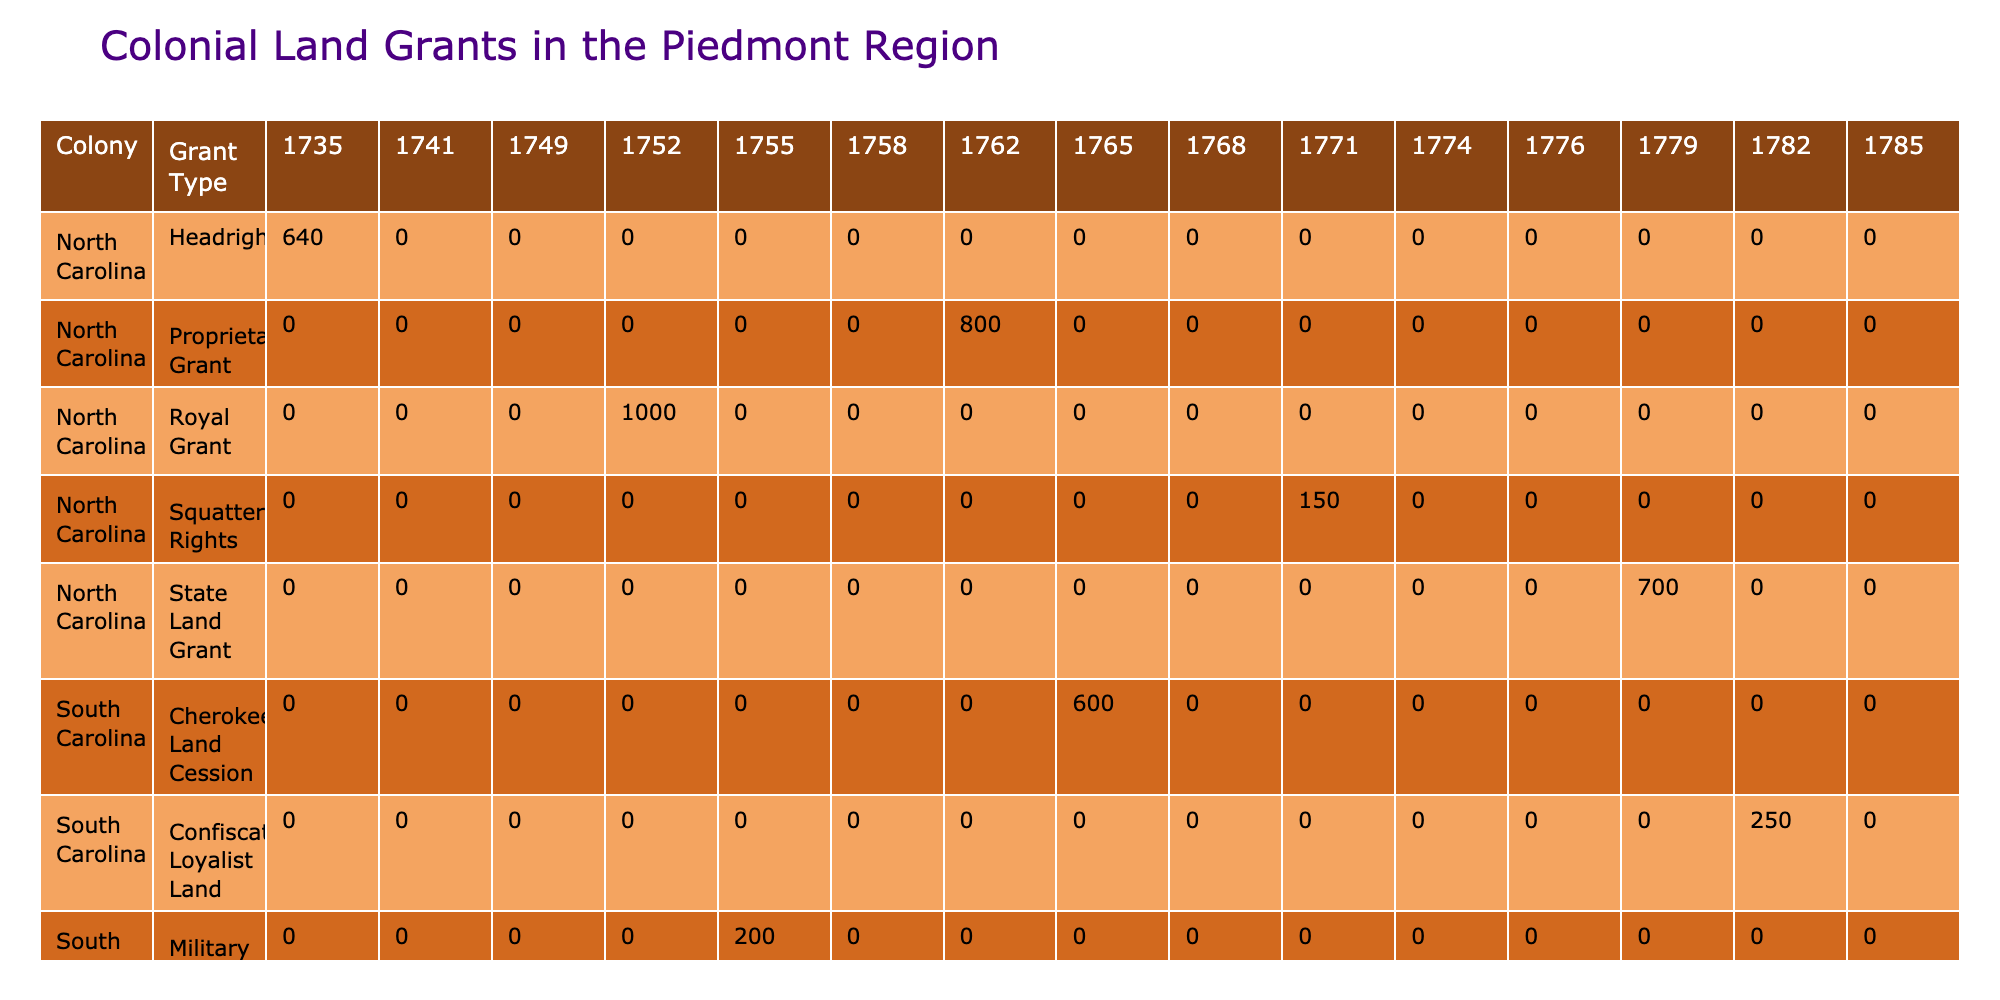What is the total acreage granted in South Carolina across all years? To find the total acreage for South Carolina, we need to sum the values in the 'Acreage' column for all the South Carolina grants listed in the table. The grants and their acreages are: 500 (17141), 200 (1755), 600 (1765), 300 (1774), and 250 (1782) which sum up to 500 + 200 + 600 + 300 + 250 = 1850.
Answer: 1850 Which grant type in Virginia had the largest acreage? Looking at the Virginia grants in the table, we see the following acreages: 320 (Purchase), 450 (Land Patent), 550 (Proclamation Line Grant), 400 (Preemption Warrant), and 350 (Treasury Warrant). The largest acreage is 550 associated with the Proclamation Line Grant.
Answer: Proclamation Line Grant How many different types of grants were issued in North Carolina? The grants listed for North Carolina are: Headright, Royal Grant, Proprietary Grant, Squatter's Rights, and State Land Grant. This gives us a total of 5 different types.
Answer: 5 Is there any military grant recorded in South Carolina? In the table, there is one entry labeled as Military Grant for South Carolina with an acreage of 200 granted to Robert Gould in 1755. Therefore, the answer to this question is yes.
Answer: Yes What is the average acreage of the land grants in Virginia? To find the average acreage of the grants in Virginia, we first sum the acreages: 320 (Purchase) + 450 (Land Patent) + 550 (Proclamation Line Grant) + 400 (Preemption Warrant) + 350 (Treasury Warrant) = 2070. There are 5 grants in total, so we divide 2070 by 5, yielding an average of 414.
Answer: 414 Which colony had the highest total acreage granted across all years? We need to sum the acreage for each colony: North Carolina (640 + 1000 + 800 + 150 + 700 = 3290), South Carolina (500 + 200 + 600 + 300 + 250 = 1850), and Virginia (320 + 450 + 550 + 400 + 350 = 2070). The total acreage for North Carolina is the highest at 3290.
Answer: North Carolina 